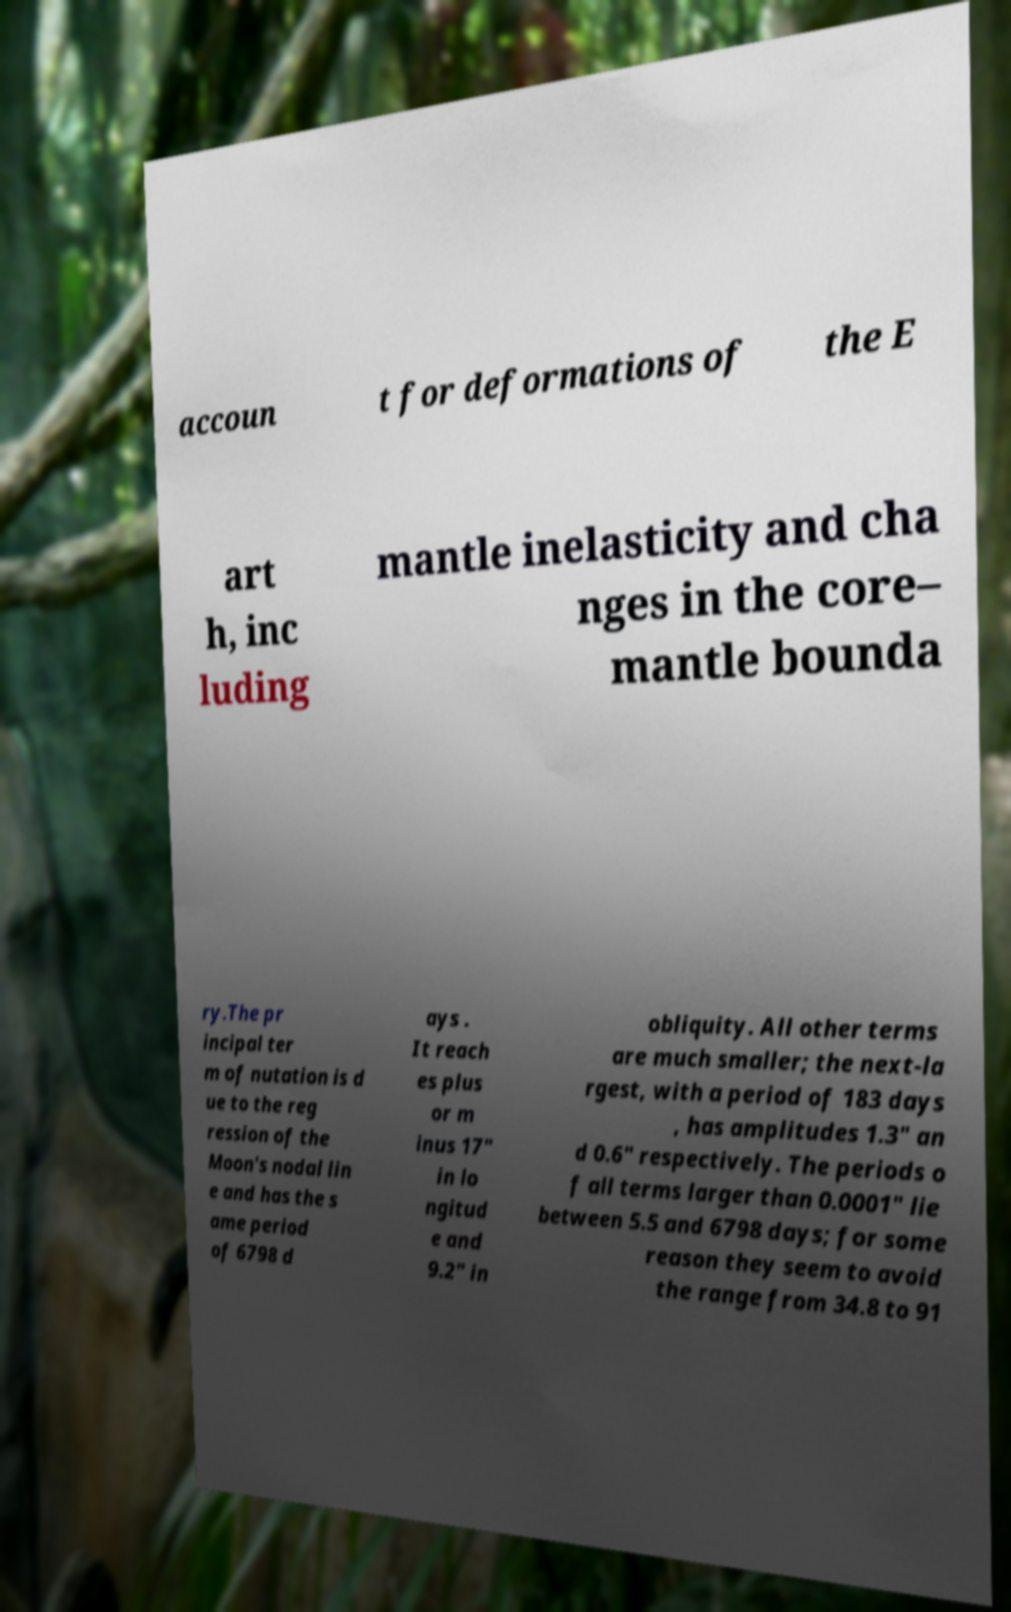Please read and relay the text visible in this image. What does it say? accoun t for deformations of the E art h, inc luding mantle inelasticity and cha nges in the core– mantle bounda ry.The pr incipal ter m of nutation is d ue to the reg ression of the Moon's nodal lin e and has the s ame period of 6798 d ays . It reach es plus or m inus 17″ in lo ngitud e and 9.2″ in obliquity. All other terms are much smaller; the next-la rgest, with a period of 183 days , has amplitudes 1.3″ an d 0.6″ respectively. The periods o f all terms larger than 0.0001″ lie between 5.5 and 6798 days; for some reason they seem to avoid the range from 34.8 to 91 